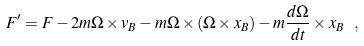Convert formula to latex. <formula><loc_0><loc_0><loc_500><loc_500>F ^ { \prime } = F - 2 m \Omega \times v _ { B } - m \Omega \times ( \Omega \times x _ { B } ) - m { \frac { d \Omega } { d t } } \times x _ { B } \ ,</formula> 